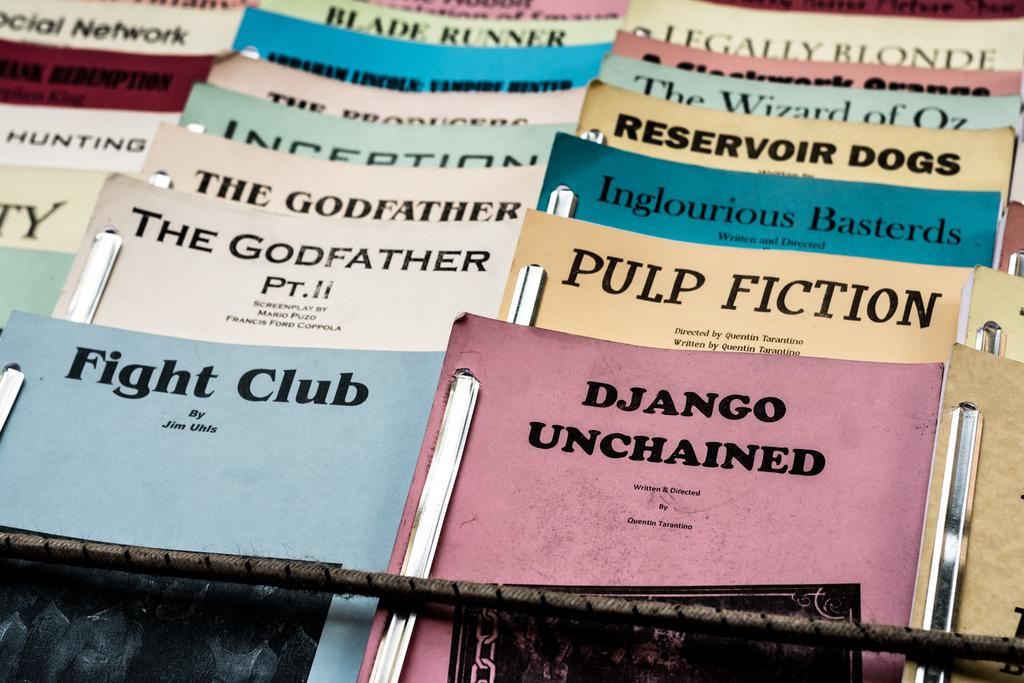Provide a one-sentence caption for the provided image. Many pamphlets including one that says Pulp Fiction. 